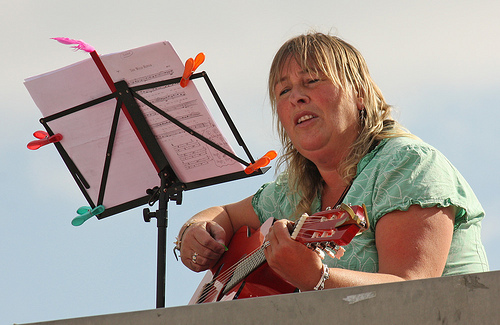<image>
Can you confirm if the music is in front of the guitar? Yes. The music is positioned in front of the guitar, appearing closer to the camera viewpoint. Is there a music sheet in front of the instrument? Yes. The music sheet is positioned in front of the instrument, appearing closer to the camera viewpoint. Is the lady in front of the clip? No. The lady is not in front of the clip. The spatial positioning shows a different relationship between these objects. 